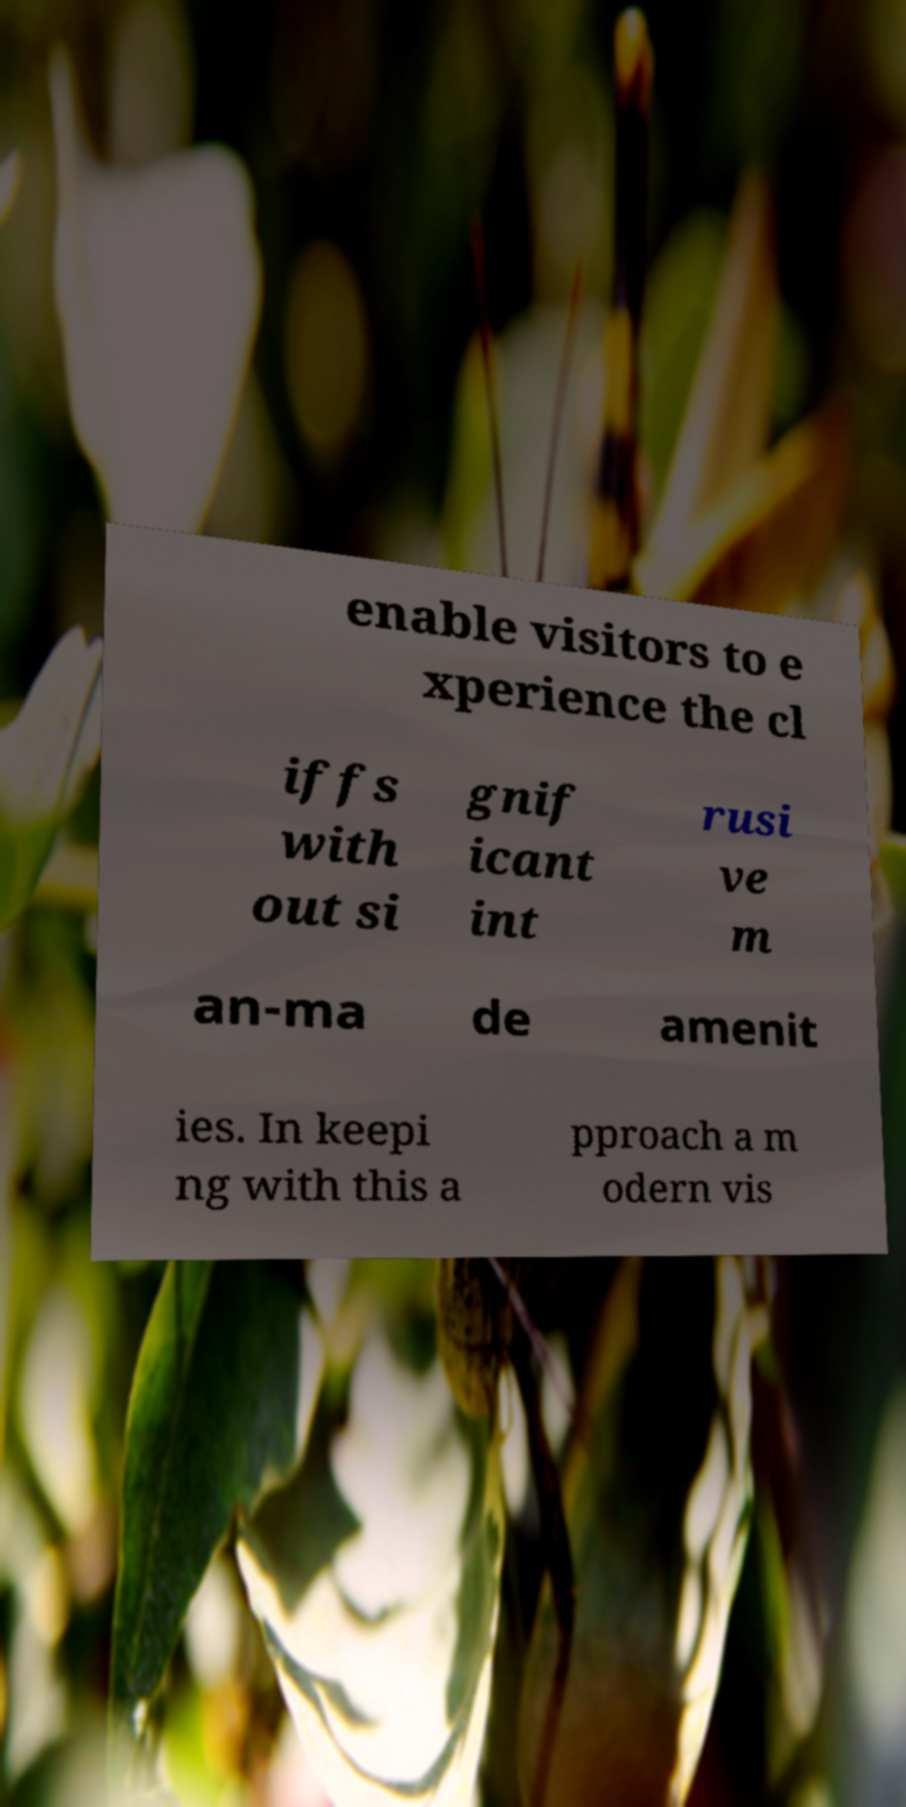Please read and relay the text visible in this image. What does it say? enable visitors to e xperience the cl iffs with out si gnif icant int rusi ve m an-ma de amenit ies. In keepi ng with this a pproach a m odern vis 